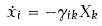Convert formula to latex. <formula><loc_0><loc_0><loc_500><loc_500>\dot { x } _ { i } = - \gamma _ { i k } X _ { k }</formula> 